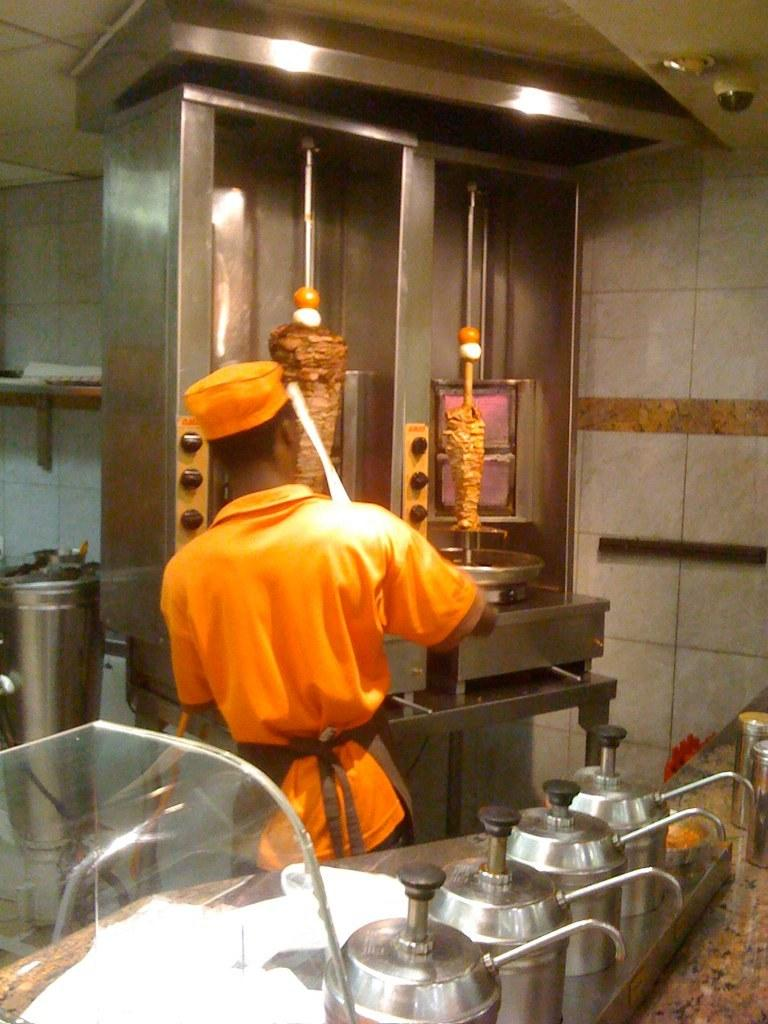What is the person in the image doing? The person is standing at a grilling machine in the image. What other items can be seen at the bottom of the image? Kettles are visible at the bottom of the image. What surface is the grilling machine placed on? There is a countertop in the image. What can be seen in the background of the image? There is a wall in the background of the image. What type of music can be heard coming from the bridge in the image? There is no bridge present in the image, so it is not possible to determine what type of music might be heard. 